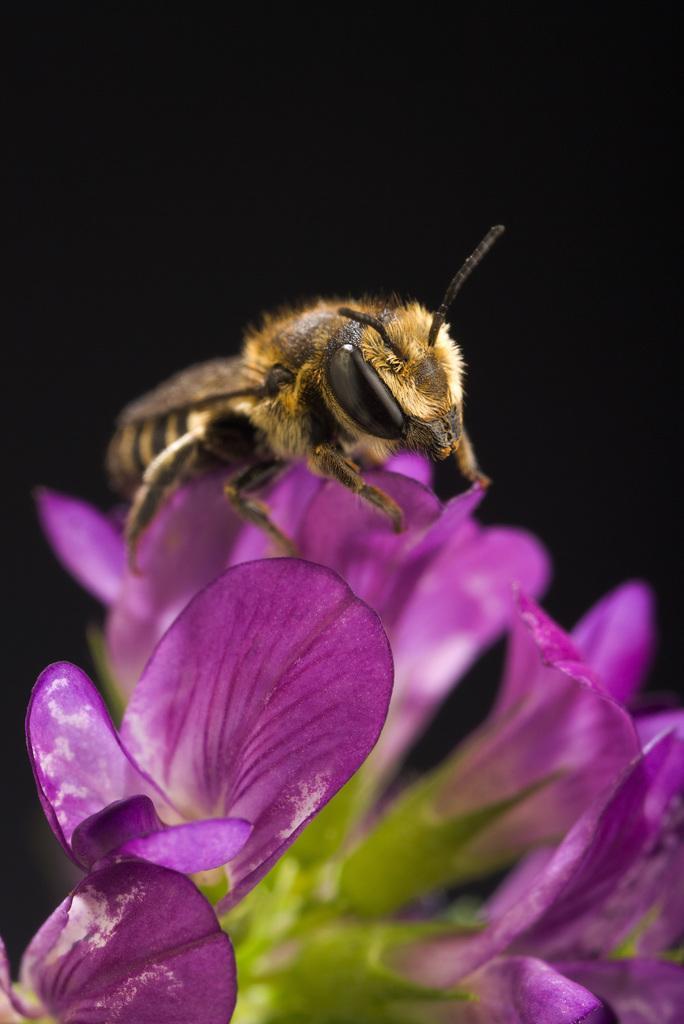Please provide a concise description of this image. This is an insect on the flower. These flowers are violet in color. The background looks dark. 